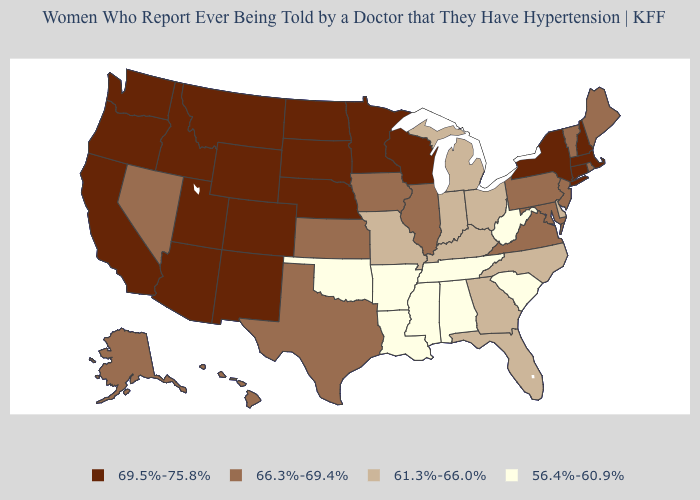Does Alabama have the highest value in the South?
Be succinct. No. Does the map have missing data?
Short answer required. No. What is the value of Texas?
Write a very short answer. 66.3%-69.4%. Does New Hampshire have the highest value in the USA?
Give a very brief answer. Yes. Does the first symbol in the legend represent the smallest category?
Quick response, please. No. Does Arkansas have the same value as Florida?
Write a very short answer. No. Which states hav the highest value in the MidWest?
Answer briefly. Minnesota, Nebraska, North Dakota, South Dakota, Wisconsin. Name the states that have a value in the range 66.3%-69.4%?
Write a very short answer. Alaska, Hawaii, Illinois, Iowa, Kansas, Maine, Maryland, Nevada, New Jersey, Pennsylvania, Rhode Island, Texas, Vermont, Virginia. What is the value of Connecticut?
Be succinct. 69.5%-75.8%. What is the lowest value in the West?
Short answer required. 66.3%-69.4%. Does Wisconsin have the lowest value in the USA?
Concise answer only. No. Among the states that border Wisconsin , which have the highest value?
Be succinct. Minnesota. Which states have the lowest value in the USA?
Short answer required. Alabama, Arkansas, Louisiana, Mississippi, Oklahoma, South Carolina, Tennessee, West Virginia. Name the states that have a value in the range 61.3%-66.0%?
Give a very brief answer. Delaware, Florida, Georgia, Indiana, Kentucky, Michigan, Missouri, North Carolina, Ohio. What is the lowest value in the USA?
Concise answer only. 56.4%-60.9%. 